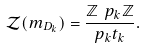Convert formula to latex. <formula><loc_0><loc_0><loc_500><loc_500>\mathcal { Z } ( m _ { D _ { k } } ) = \frac { \mathbb { Z } \ p _ { k } \mathbb { Z } } { p _ { k } t _ { k } } .</formula> 